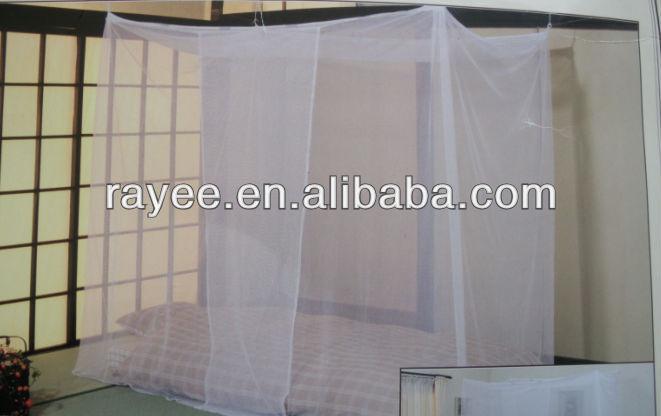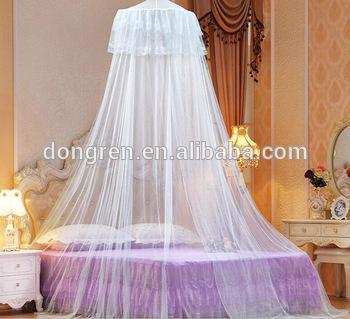The first image is the image on the left, the second image is the image on the right. Evaluate the accuracy of this statement regarding the images: "The netting in the image on the left is suspended from its corners.". Is it true? Answer yes or no. Yes. 